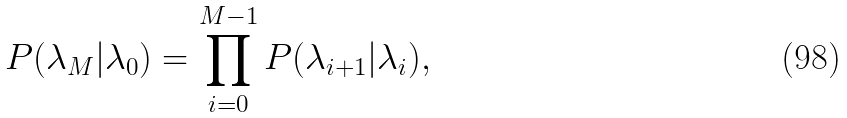Convert formula to latex. <formula><loc_0><loc_0><loc_500><loc_500>P ( \lambda _ { M } | \lambda _ { 0 } ) = \prod _ { i = 0 } ^ { M - 1 } P ( \lambda _ { i + 1 } | \lambda _ { i } ) ,</formula> 